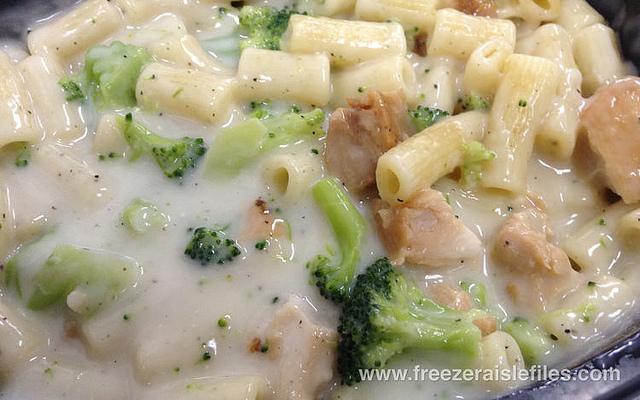How many broccolis are there?
Give a very brief answer. 6. How many zebras are here?
Give a very brief answer. 0. 